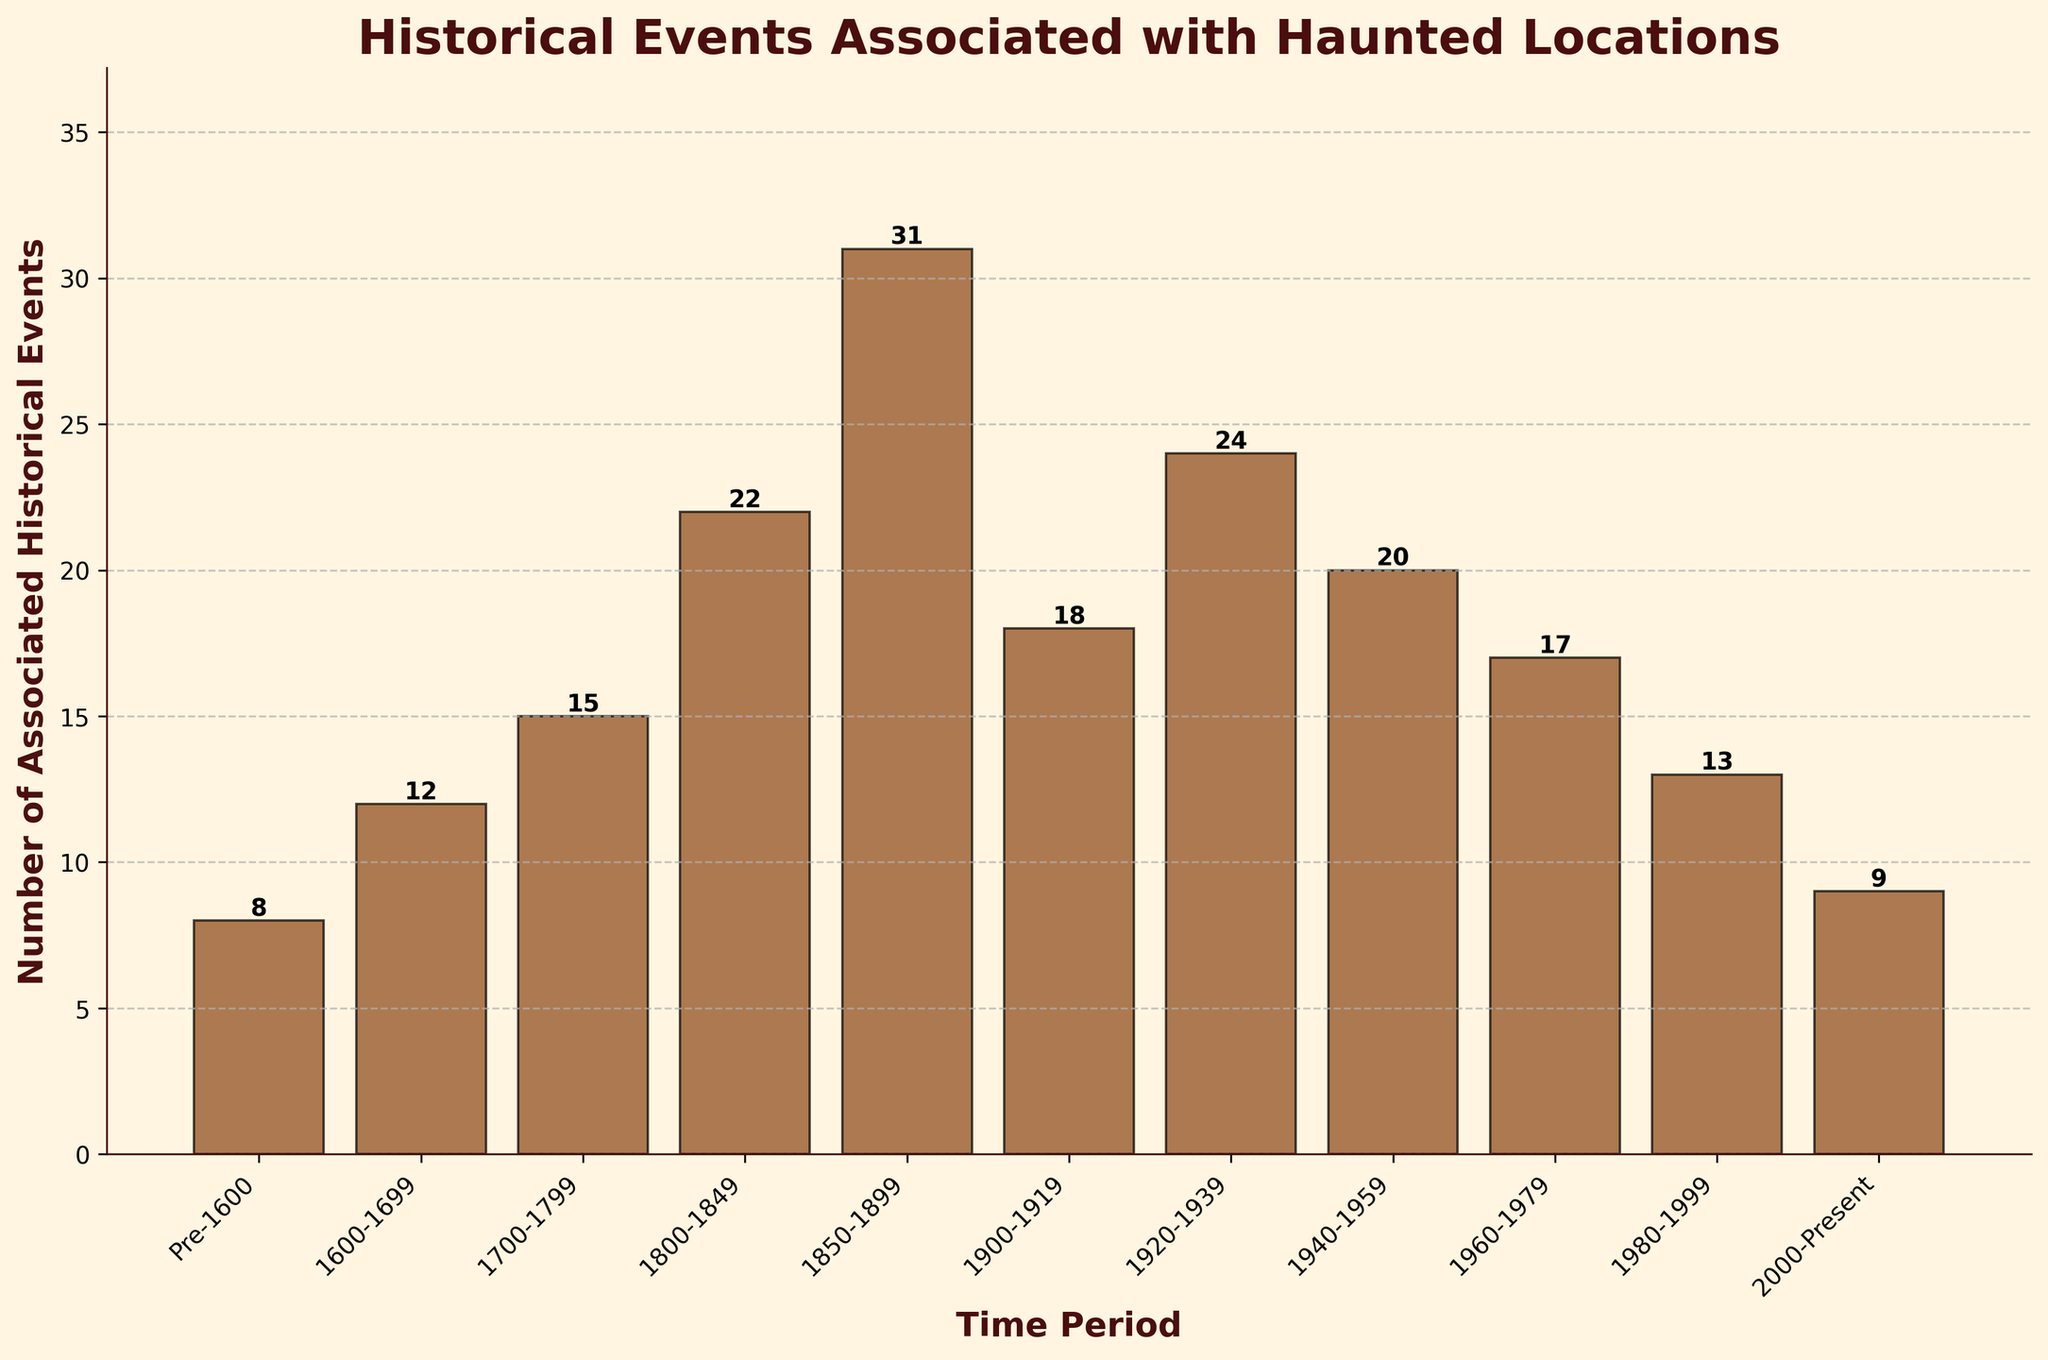What's the time period with the highest number of associated historical events? The height of the bars represents the number of historical events. The bar for 1850-1899 is the tallest, indicating it has the highest count.
Answer: 1850-1899 How many historical events are associated with haunted locations in the periods from 1600 to 1799 combined? Adding the events from 1600-1699 (12) and 1700-1799 (15) gives 12 + 15 = 27.
Answer: 27 What is the difference in the number of historical events between 1800-1849 and 1980-1999? Subtract the number of events in 1980-1999 (13) from 1800-1849 (22), which is 22 - 13.
Answer: 9 Which period has fewer associated historical events, the 1920-1939 period or the 1960-1979 period? By comparing the heights of the bars, 1960-1979 has 17 events and 1920-1939 has 24. The 1960-1979 period has fewer.
Answer: 1960-1979 What is the average number of historical events for the periods 1900-1919, 1920-1939, and 1940-1959? Sum the events for these periods and divide by the number of periods: (18 + 24 + 20) / 3 = 62 / 3.
Answer: 20.67 Which time period immediately follows the time period with the highest number of historical events? The period with the highest events is 1850-1899, and the following period is 1900-1919.
Answer: 1900-1919 Are there more or fewer historical events from 2000-Present compared to Pre-1600? Compare the heights; Pre-1600 has 8 events, while 2000-Present has 9. There are more in 2000-Present
Answer: Fewer In which century (1600-1699, 1700-1799, 1800-1899) is the average number of historical events the highest, and what is that average? Average for 1600-1699: 12; for 1700-1799: 15; and for 1800-1899: (22 + 31) / 2 = 26.5. The highest average is in the 1800-1899 century.
Answer: 26.5 Is the total number of historical events for the periods after 1940 greater than before 1940? Events after 1940: 20 + 17 + 13 + 9 = 59. Events before 1940: 8 + 12 + 15 + 22 + 31 + 18 + 24 = 130. There are fewer events after 1940.
Answer: No Which period between 1800-1999 has a higher number of historical events: 1900-1919 or 1960-1979? Compare the events: 1960-1979 has 17, and 1900-1919 has 18.
Answer: 1900-1919 